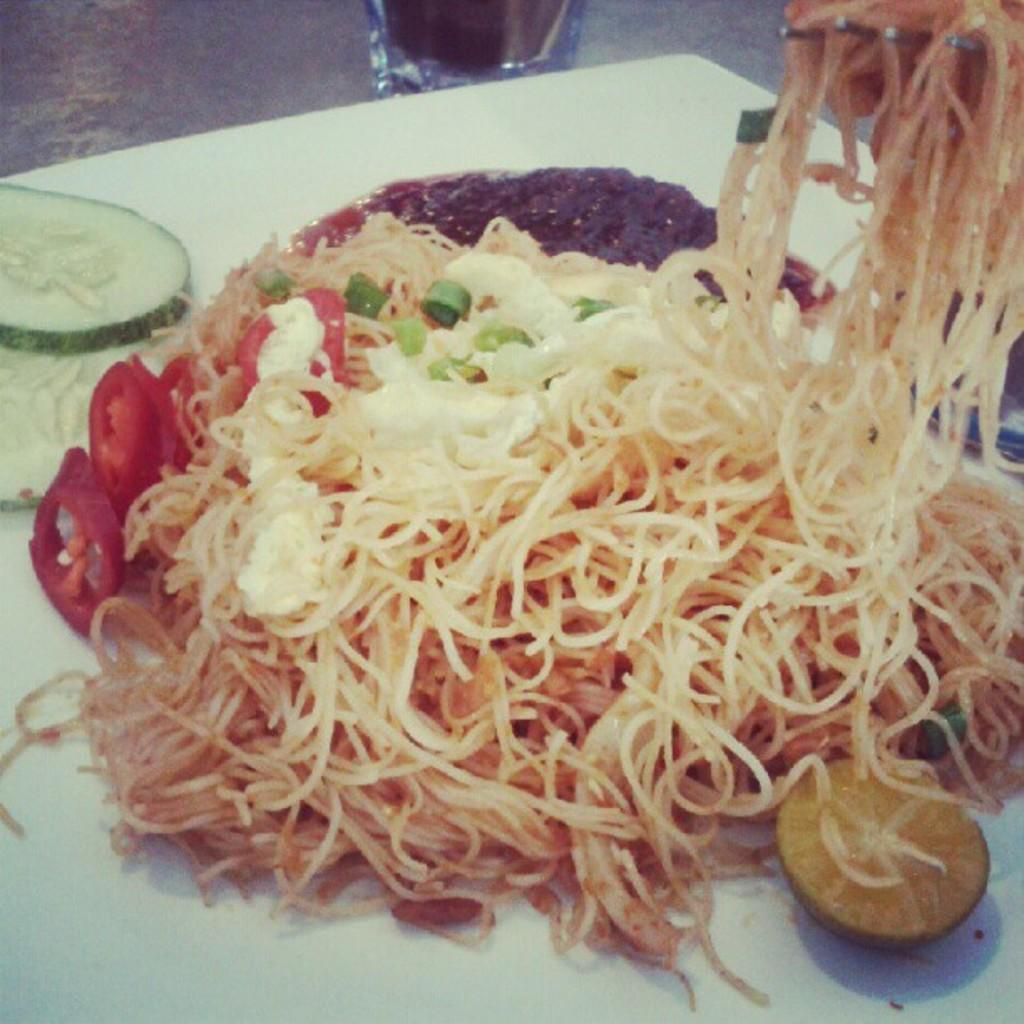What is on the plate that is visible in the image? The plate contains noodles and tomato slices. What else is on the plate besides the noodles and tomato slices? There is sauce on the plate. What is located beside the plate in the image? There is a lemon piece beside the plate. Who is the owner of the office where the plate is located in the image? There is no information about an office or an owner in the image; it only shows a plate with noodles, tomato slices, sauce, and a lemon piece. 